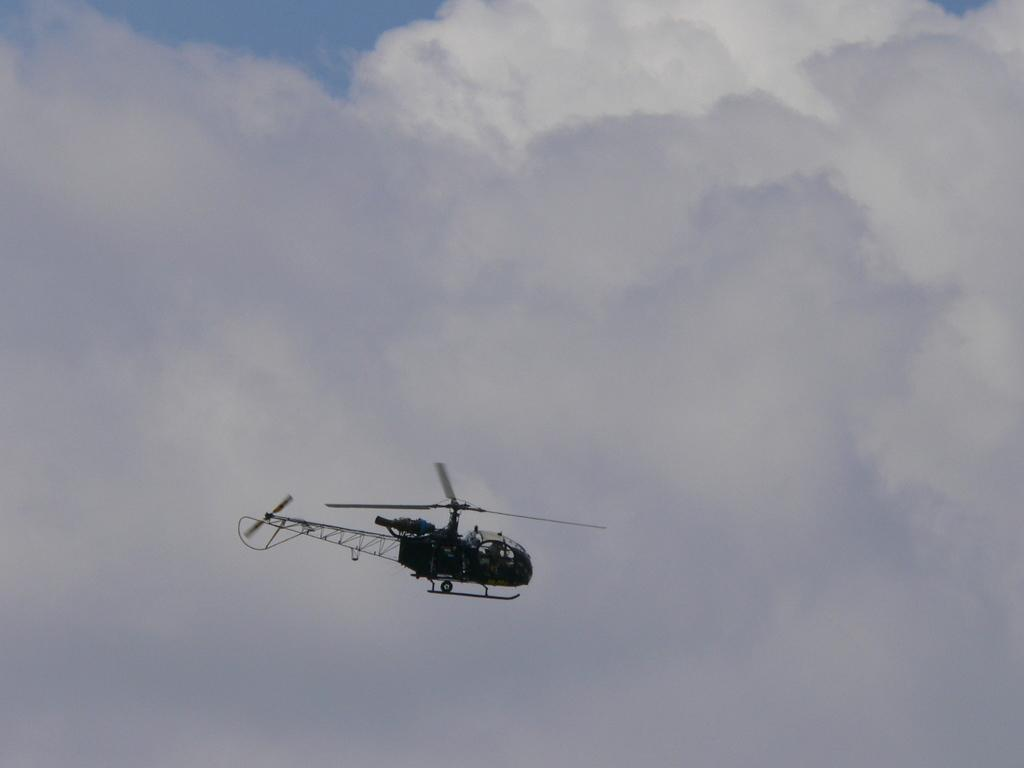What is the main subject of the image? The main subject of the image is a helicopter. What is the helicopter doing in the image? The helicopter is flying in the sky. How would you describe the sky in the image? The sky is cloudy. Can you see any toads or rabbits in the image? No, there are no toads or rabbits present in the image. What type of insect can be seen flying alongside the helicopter in the image? There are no insects visible in the image; only the helicopter is present. 